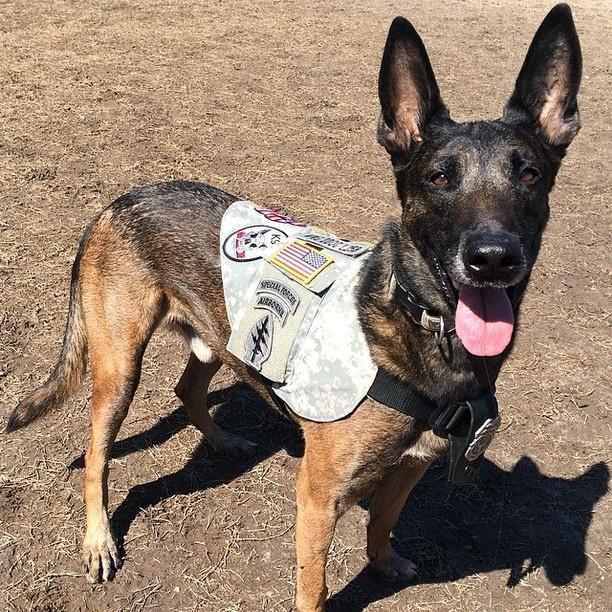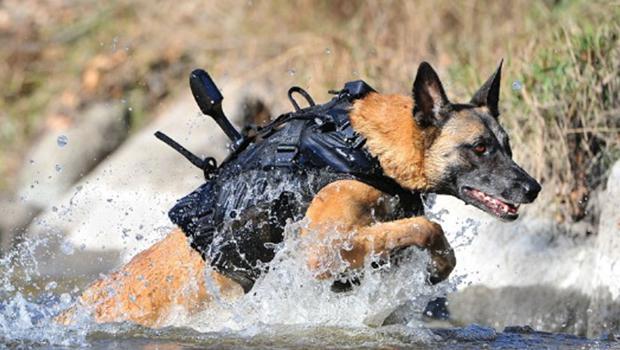The first image is the image on the left, the second image is the image on the right. Given the left and right images, does the statement "A person in camo attire interacts with a dog in both images." hold true? Answer yes or no. No. 